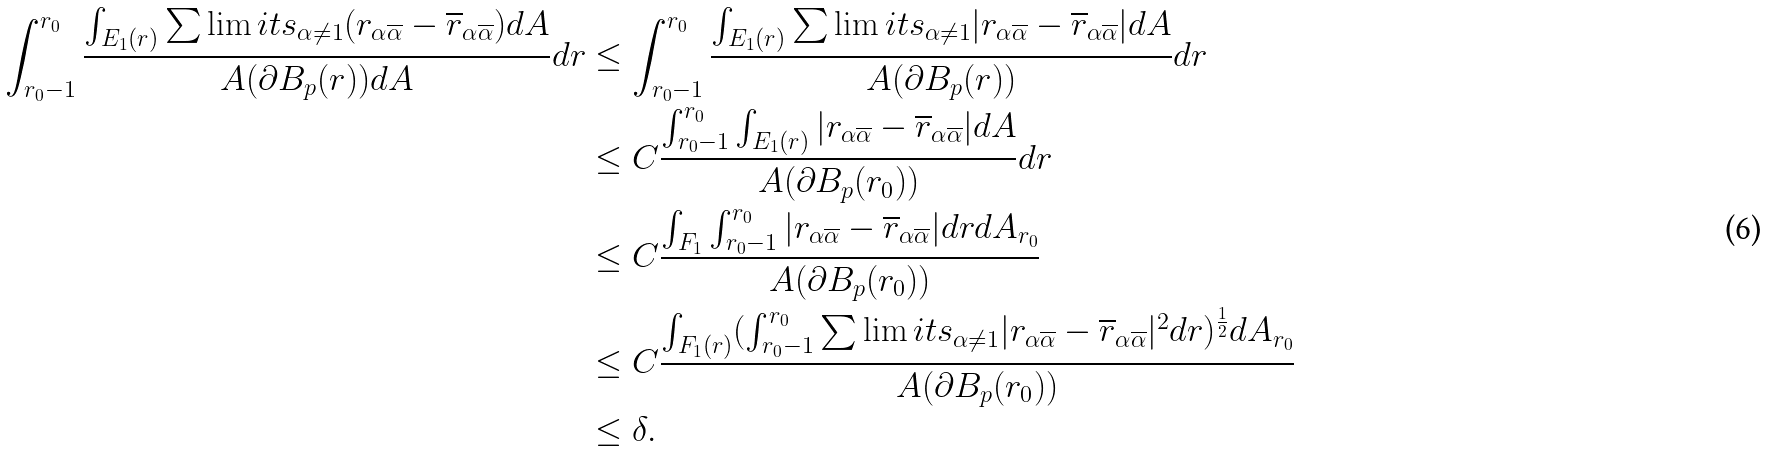<formula> <loc_0><loc_0><loc_500><loc_500>\int _ { r _ { 0 } - 1 } ^ { r _ { 0 } } \frac { \int _ { E _ { 1 } ( r ) } \sum \lim i t s _ { \alpha \neq 1 } ( r _ { \alpha \overline { \alpha } } - \overline { r } _ { \alpha \overline { \alpha } } ) d A } { A ( \partial B _ { p } ( r ) ) d A } d r & \leq \int _ { r _ { 0 } - 1 } ^ { r _ { 0 } } \frac { \int _ { E _ { 1 } ( r ) } \sum \lim i t s _ { \alpha \neq 1 } | r _ { \alpha \overline { \alpha } } - \overline { r } _ { \alpha \overline { \alpha } } | d A } { A ( \partial B _ { p } ( r ) ) } d r \\ & \leq C \frac { \int _ { r _ { 0 } - 1 } ^ { r _ { 0 } } \int _ { E _ { 1 } ( r ) } | r _ { \alpha \overline { \alpha } } - \overline { r } _ { \alpha \overline { \alpha } } | d A } { A ( \partial B _ { p } ( r _ { 0 } ) ) } d r \\ & \leq C \frac { \int _ { F _ { 1 } } \int _ { r _ { 0 } - 1 } ^ { r _ { 0 } } | r _ { \alpha \overline { \alpha } } - \overline { r } _ { \alpha \overline { \alpha } } | d r d A _ { r _ { 0 } } } { A ( \partial B _ { p } ( r _ { 0 } ) ) } \\ & \leq C \frac { \int _ { F _ { 1 } ( r ) } ( \int _ { r _ { 0 } - 1 } ^ { r _ { 0 } } \sum \lim i t s _ { \alpha \neq 1 } | r _ { \alpha \overline { \alpha } } - \overline { r } _ { \alpha \overline { \alpha } } | ^ { 2 } d r ) ^ { \frac { 1 } { 2 } } d A _ { r _ { 0 } } } { A ( \partial B _ { p } ( r _ { 0 } ) ) } \\ & \leq \delta .</formula> 